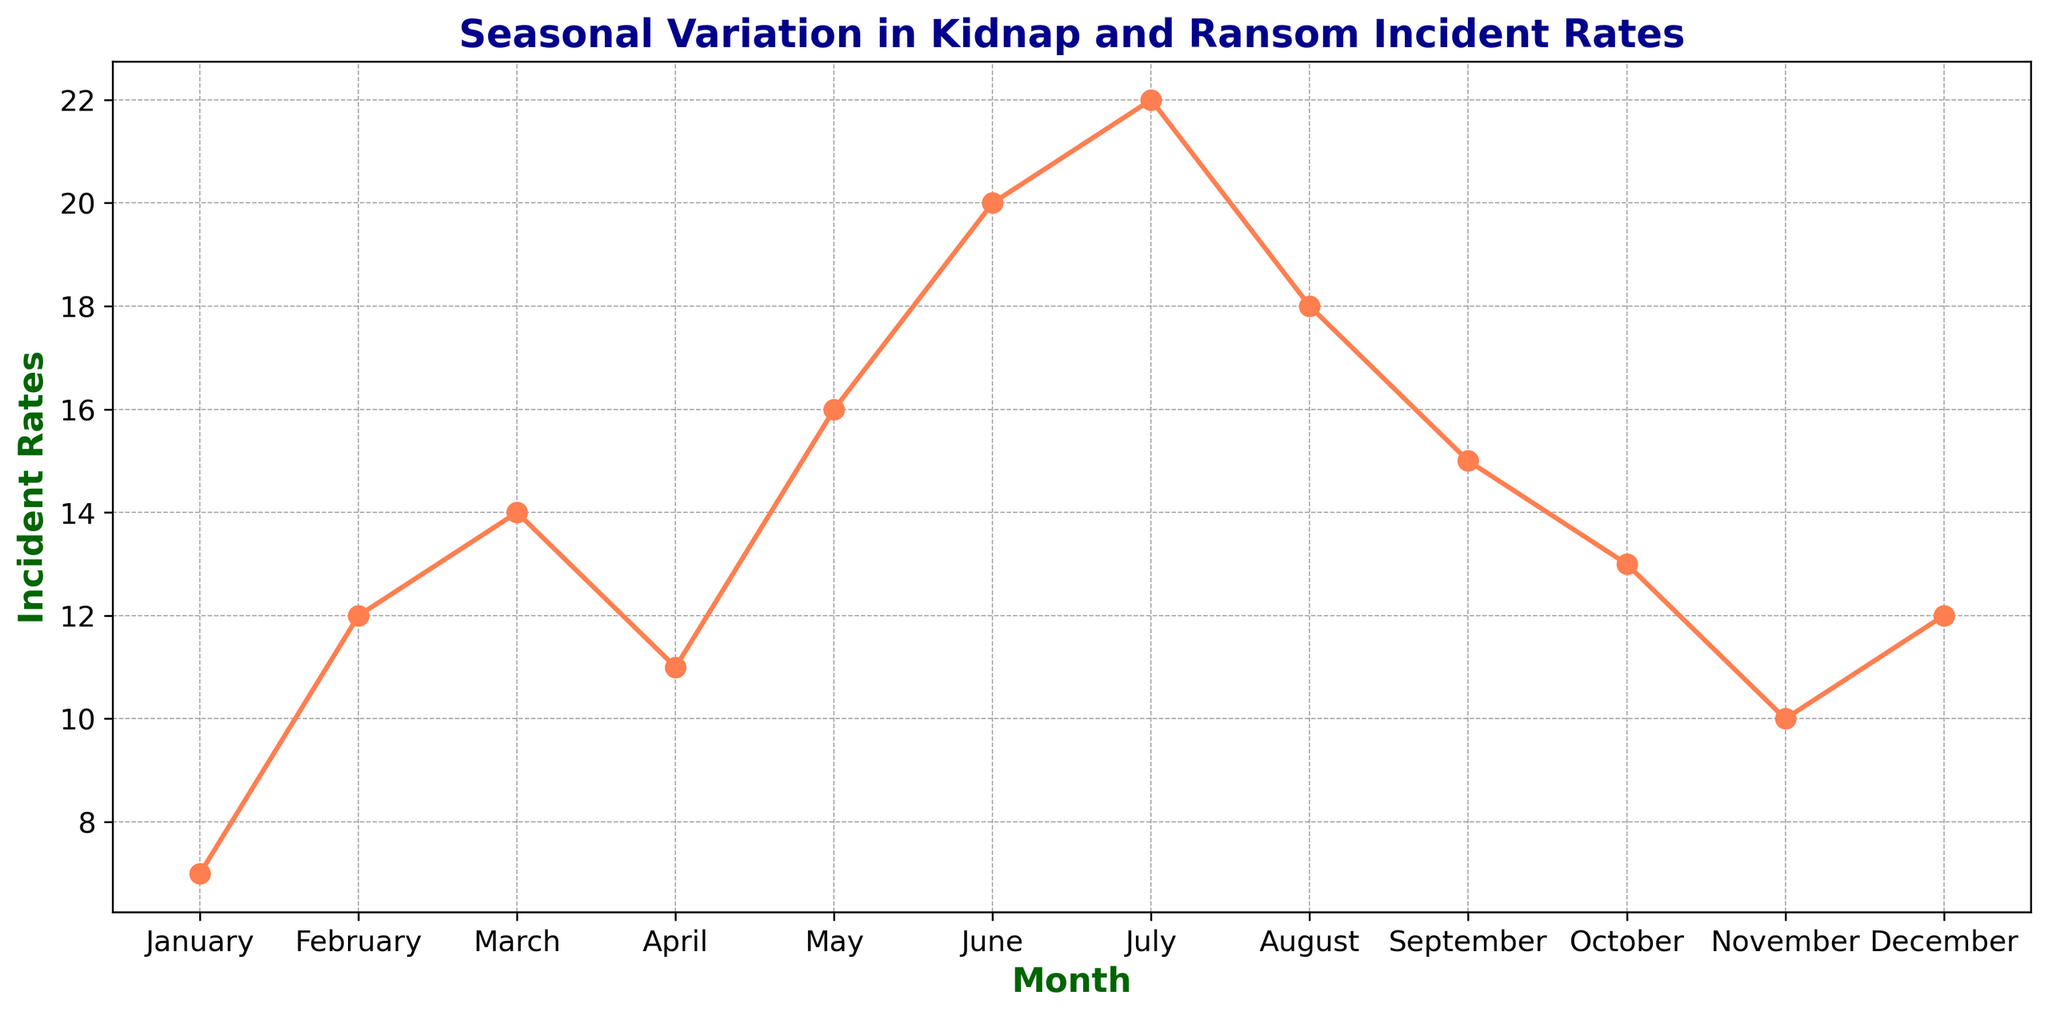What month has the highest incident rate? Observe the peaks in the line chart. From the chart, the highest peak represents July.
Answer: July Which month has a lower incident rate, October or December? Compare the incident rate values for October and December by looking at their respective points on the chart. October has 13 incidents, while December has 12.
Answer: December What's the average incident rate for the first quarter (January, February, March)? Calculate the average by summing incident rates for January, February, and March, then divide by 3. \( (7 + 12 + 14) / 3 = 33 / 3 = 11 \)
Answer: 11 Is the incident rate in June greater than the incident rate in May? Compare values directly: June has 20 incidents, and May has 16. Since 20 > 16, June has a higher incident rate.
Answer: Yes What is the incident rate difference between the peak month and the lowest month? Identify the peak month (July, 22 incidents) and the lowest month (January, 7 incidents). Subtract to find the difference: 22 - 7 = 15.
Answer: 15 How many months have incident rates above 15? Count the months with incident rates above 15 by checking each data point in the chart. May, June, July, and August all have rates above 15.
Answer: 4 What's the total incident rate for the summer months (June, July, August)? Sum the incident rates for June, July, and August: \( 20 + 22 + 18 = 60 \)
Answer: 60 Between which two consecutive months is the largest increase in incident rates observed? Observe the line chart and look for the steepest upward slope between consecutive months. The largest increase is from May to June, rising from 16 to 20 incidents (an increase of 4).
Answer: May to June Does the incident rate generally trend upwards or downwards throughout the year? Analyze the overall trend by observing the direction of the line from January to December. While there are fluctuations, there is no clear upward or downward trend as it varies throughout the months.
Answer: Neither 